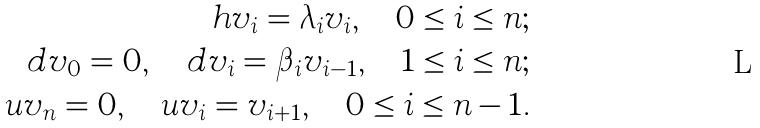Convert formula to latex. <formula><loc_0><loc_0><loc_500><loc_500>h v _ { i } = \lambda _ { i } v _ { i } , \quad 0 \leq i \leq n ; \\ d v _ { 0 } = 0 , \quad d v _ { i } = \beta _ { i } v _ { i - 1 } , \quad 1 \leq i \leq n ; \\ u v _ { n } = 0 , \quad u v _ { i } = v _ { i + 1 } , \quad 0 \leq i \leq n - 1 .</formula> 